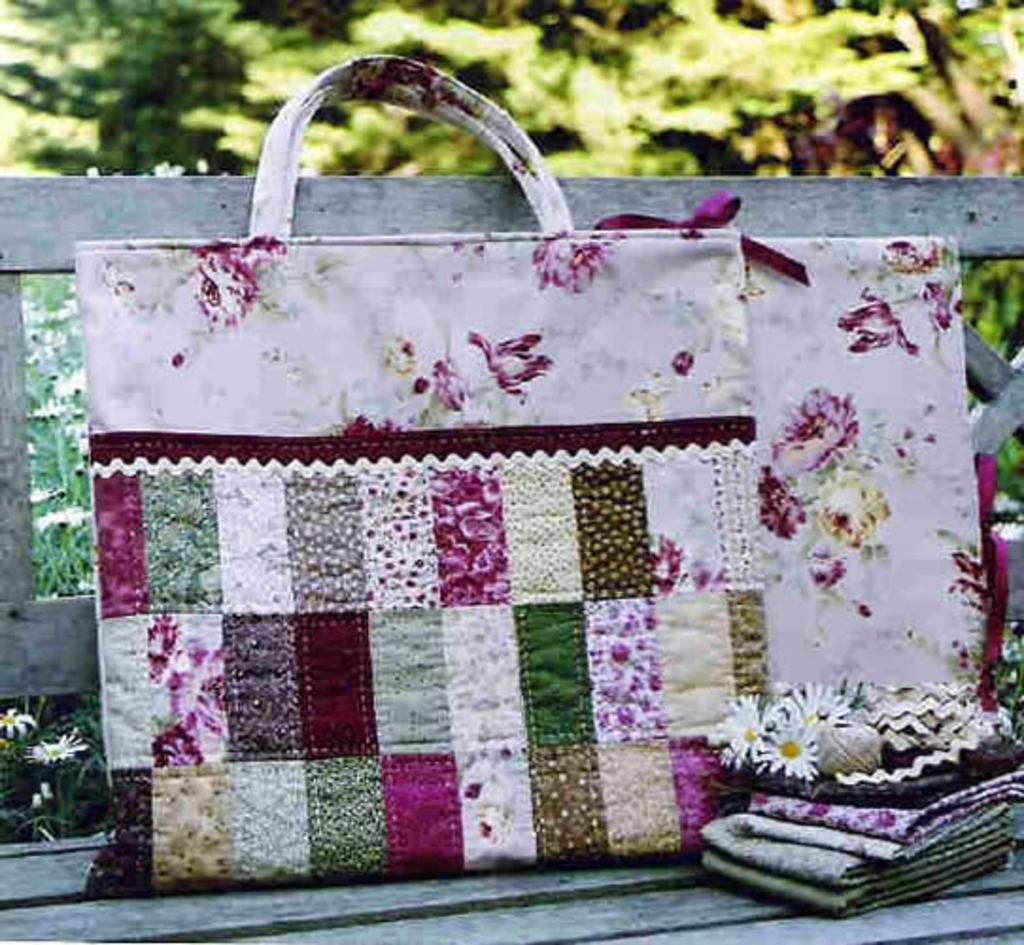What object is visible in the picture? There is a bag in the picture. Where is the bag located? The bag is placed on a bench. What else can be seen near the bag? There is a gift packing beside the bag. What can be seen in the background of the image? There are trees in the background of the image. What type of apple is being sung about in the image? There is no apple or singing present in the image. What is the color of the neck of the person in the image? There is no person present in the image, so it is not possible to determine the color of their neck. 